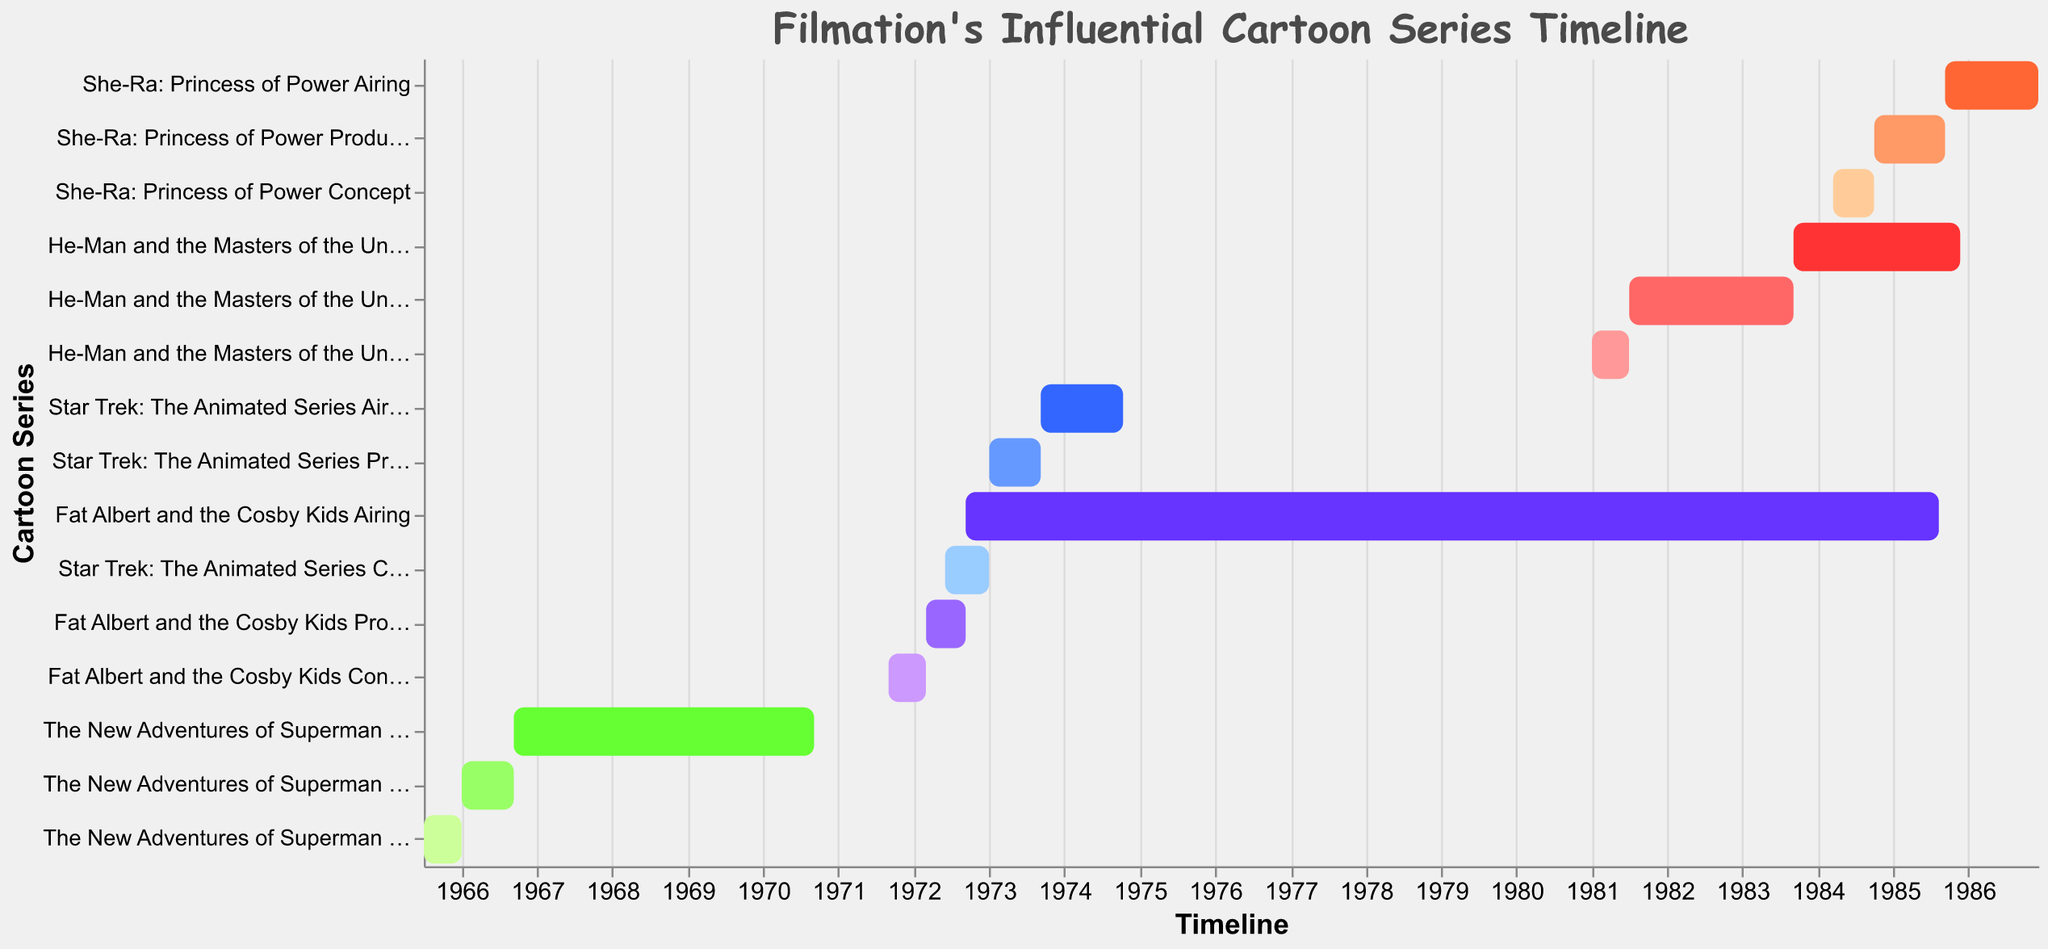What's the title of the figure? The title of the figure is located at the top and usually in a larger font size than the rest of the text. It gives an overview of what the visual representation is about.
Answer: Filmation's Influential Cartoon Series Timeline In which year did "He-Man and the Masters of the Universe" start airing? By scanning the timeline for the "He-Man and the Masters of the Universe Airing" task, we can identify the start date.
Answer: 1983 How long was the airing period for "She-Ra: Princess of Power"? Find the start and end dates for the "She-Ra: Princess of Power Airing" task and calculate the difference between these dates.
Answer: Approximately 1 year and 3 months Which series had the longest production phase? Look at the bars representing the production timeline and compare their lengths. The longest one indicates the series with the longest production phase.
Answer: He-Man and the Masters of the Universe Did "Fat Albert and the Cosby Kids" have a concept phase longer than its production phase? Compare the lengths of the bars corresponding to "Fat Albert and the Cosby Kids Concept" and "Fat Albert and the Cosby Kids Production". Measure in terms of the timeline.
Answer: No Which cartoon series was in the production phase in 1973? Identify the task bars that overlap with the timeline interval for 1973 and see which series they belong to.
Answer: Star Trek: The Animated Series Was there any cartoon series that started airing the same year its production ended? Compare the ending dates of the production phases with the starting dates of the airing phases for all series.
Answer: She-Ra: Princess of Power How many series had at least 10 years between their concept phase and their final episode? Calculate the duration from the start of the concept phase to the end of the airing phase for each series, then count those with durations of 10 years or more.
Answer: Two (The New Adventures of Superman and Fat Albert and the Cosby Kids) Which series' airing phase lasted the shortest? Compare the lengths of the bars representing the airing phases to identify the shortest one.
Answer: Star Trek: The Animated Series What was the total duration from the start of the concept phase to the end of the airing phase for "The New Adventures of Superman"? Sum the durations of the concept, production, and airing phases for "The New Adventures of Superman".
Answer: Approximately 5 years and 2 months 